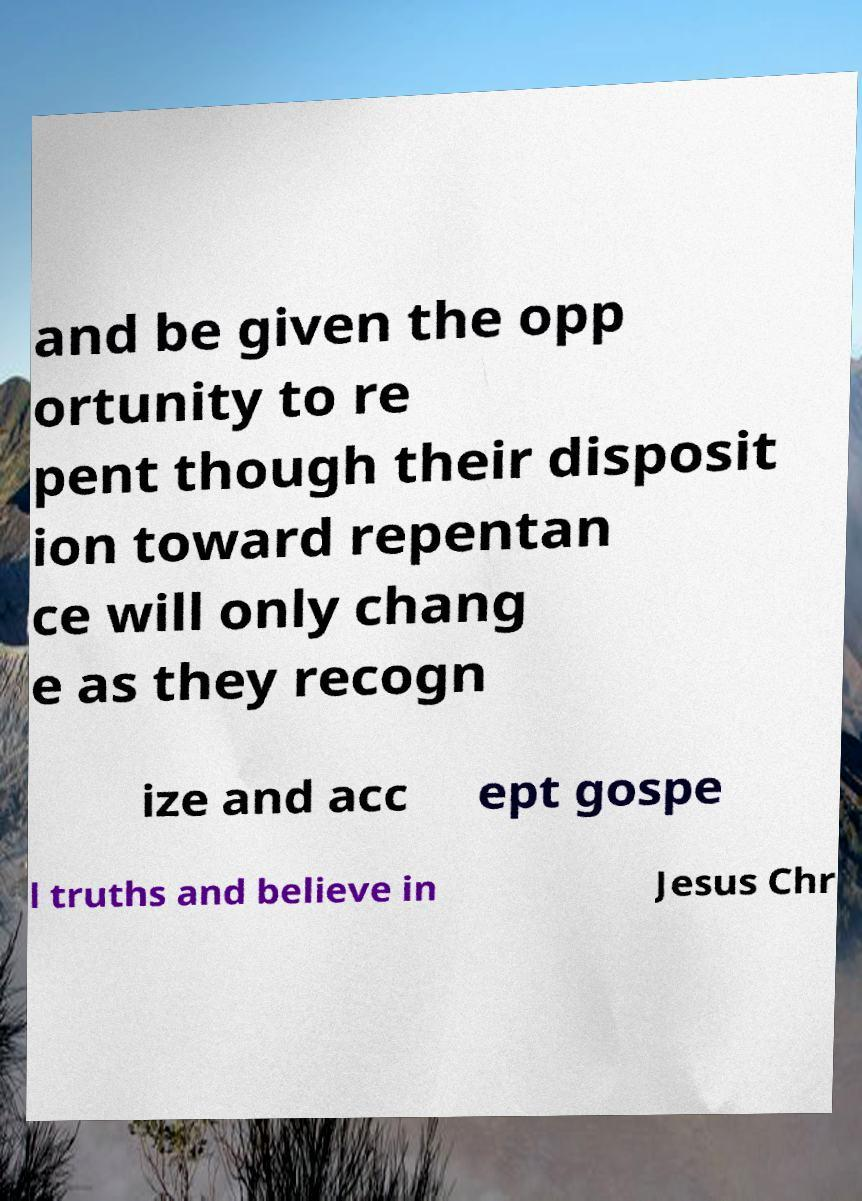There's text embedded in this image that I need extracted. Can you transcribe it verbatim? and be given the opp ortunity to re pent though their disposit ion toward repentan ce will only chang e as they recogn ize and acc ept gospe l truths and believe in Jesus Chr 